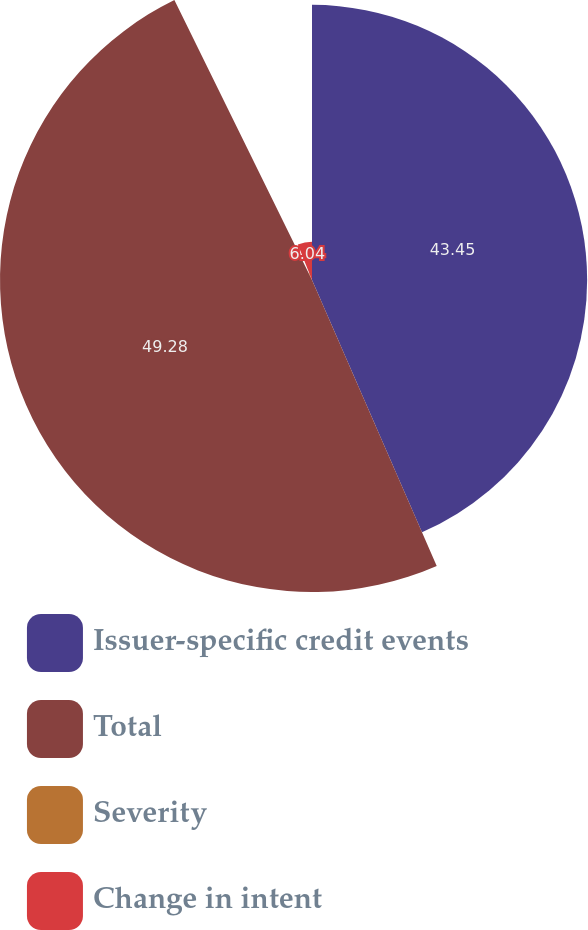<chart> <loc_0><loc_0><loc_500><loc_500><pie_chart><fcel>Issuer-specific credit events<fcel>Total<fcel>Severity<fcel>Change in intent<nl><fcel>43.45%<fcel>49.27%<fcel>1.23%<fcel>6.04%<nl></chart> 